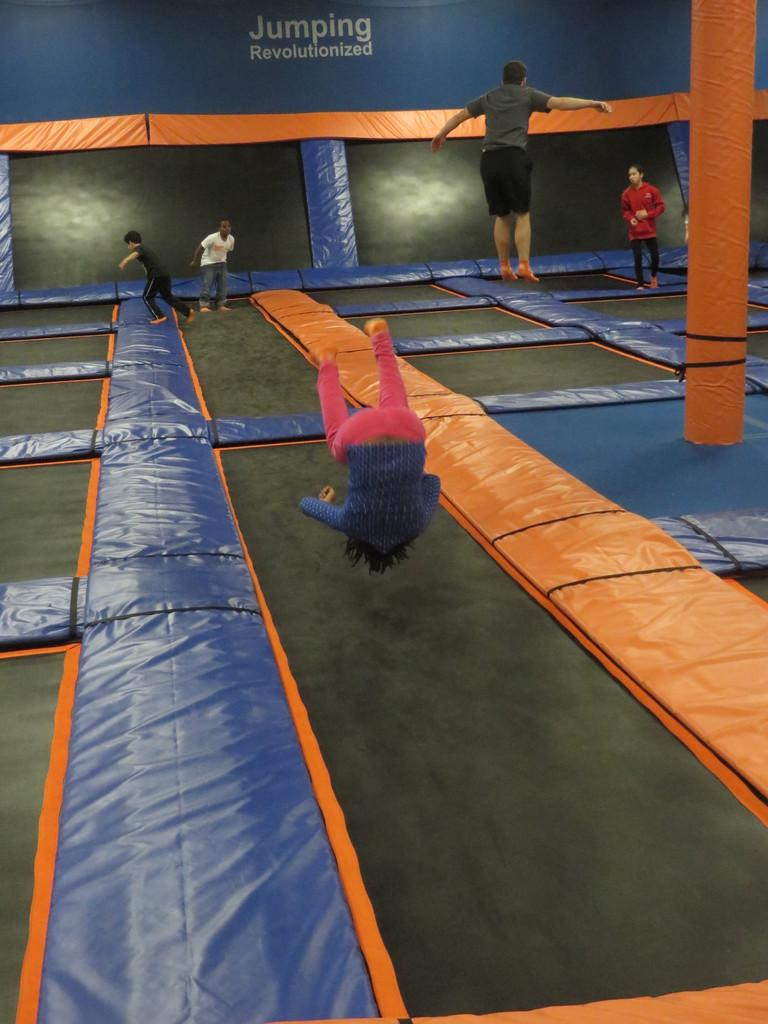What are the people in the image doing? The people are jumping on a trampoline. What is covering the trampoline? The trampoline is covered all over. What can be seen on the right side of the image? There is a pillar present on the right side of the image. What is the stomach of the person in the front doing while jumping on the trampoline? There is no information about the stomach of any person in the image, as the focus is on their actions and the trampoline's condition. 